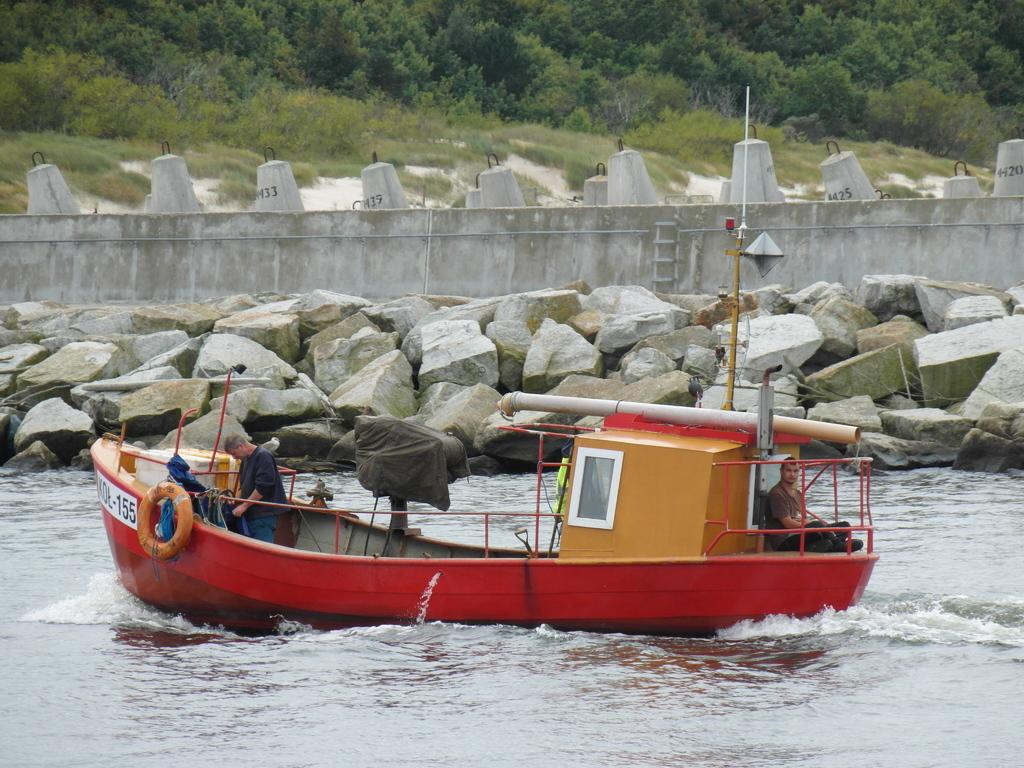What is the main subject in the center of the image? There is a boat in the center of the image. Where is the boat located? The boat is on the water. Are there any people in the boat? Yes, there are people in the boat. What can be seen in the background of the image? There are rocks, a wall, and trees in the background of the image. What is visible at the bottom of the image? Water is visible at the bottom of the image. What type of feather can be seen floating on the water in the image? There is no feather visible in the image; it only features a boat, people, and background elements. 